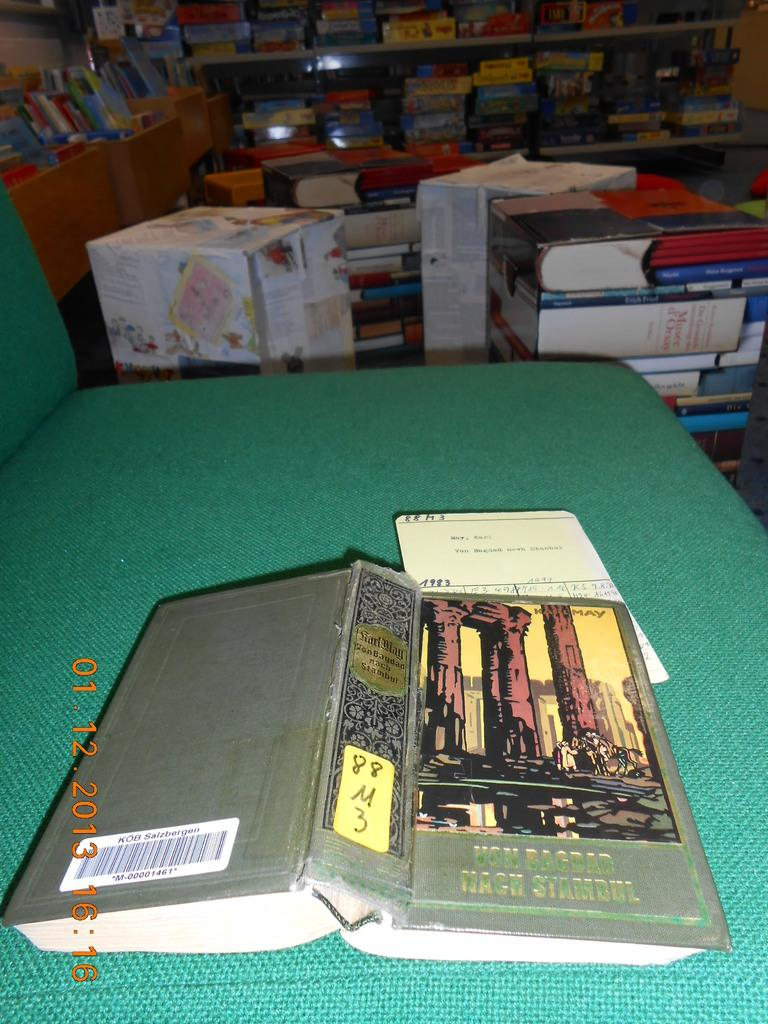<image>
Render a clear and concise summary of the photo. The front of a German book called Von Bagdad 